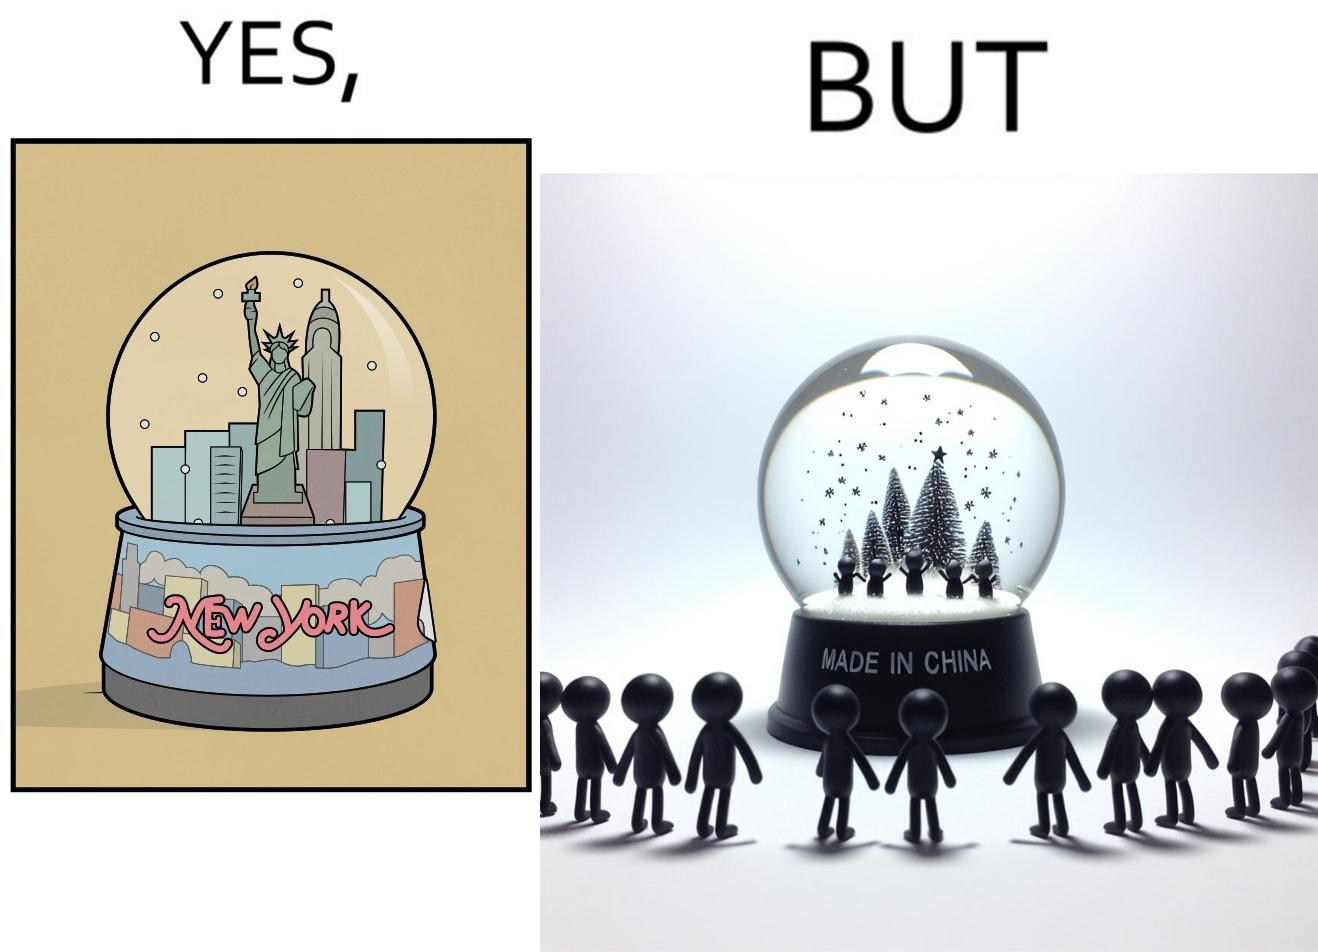Explain the humor or irony in this image. The image is ironic because the snowglobe says 'New York' while it is made in China 